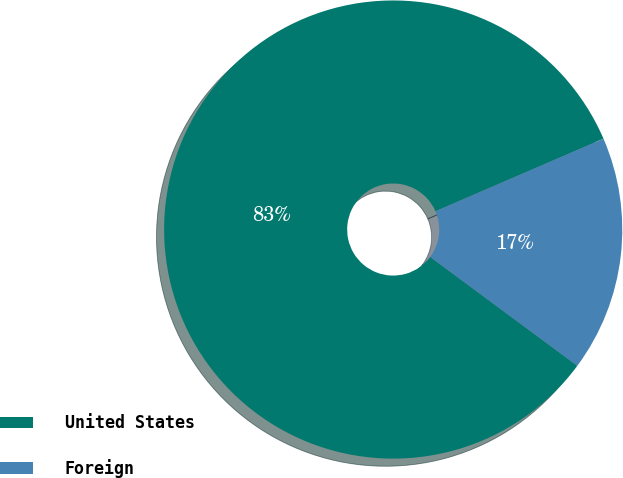<chart> <loc_0><loc_0><loc_500><loc_500><pie_chart><fcel>United States<fcel>Foreign<nl><fcel>83.37%<fcel>16.63%<nl></chart> 